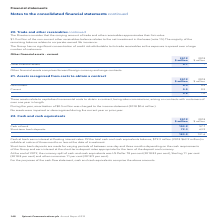According to Spirent Communications Plc's financial document, What amount of the total cash and cash equivalents balance is callable at notice of three months or less at the date of investment in 2019? According to the financial document, $79.3 million. The relevant text states: "s. Of the total cash and cash equivalents balance, $79.3 million (2018 $63.9 million) is callable at notice of three months or less at the date of investment...." Also, What are short-term bank deposits made for? varying periods of between one day and three months depending on the cash requirements of the Group and earn interest at the short-term deposit rates appropriate for the term of the deposit and currency.. The document states: "Short-term bank deposits are made for varying periods of between one day and three months depending on the cash requirements of the Group and earn int..." Also, What are the items under cash and cash equivalents, for the purposes of the cash flow statement? The document shows two values: Cash at bank and Short-term bank deposits. From the document: "Short-term bank deposits 79.3 63.9 Cash at bank 103.9 57.7..." Additionally, In which year was the amount of short-term bank deposits larger? According to the financial document, 2019. The relevant text states: "2019 2018..." Also, can you calculate: What was the change in the cash at bank? Based on the calculation: 103.9-57.7, the result is 46.2 (in millions). This is based on the information: "Cash at bank 103.9 57.7 Cash at bank 103.9 57.7..." The key data points involved are: 103.9, 57.7. Also, can you calculate: What was the percentage change in the cash at bank? To answer this question, I need to perform calculations using the financial data. The calculation is: (103.9-57.7)/57.7, which equals 80.07 (percentage). This is based on the information: "Cash at bank 103.9 57.7 Cash at bank 103.9 57.7..." The key data points involved are: 103.9, 57.7. 